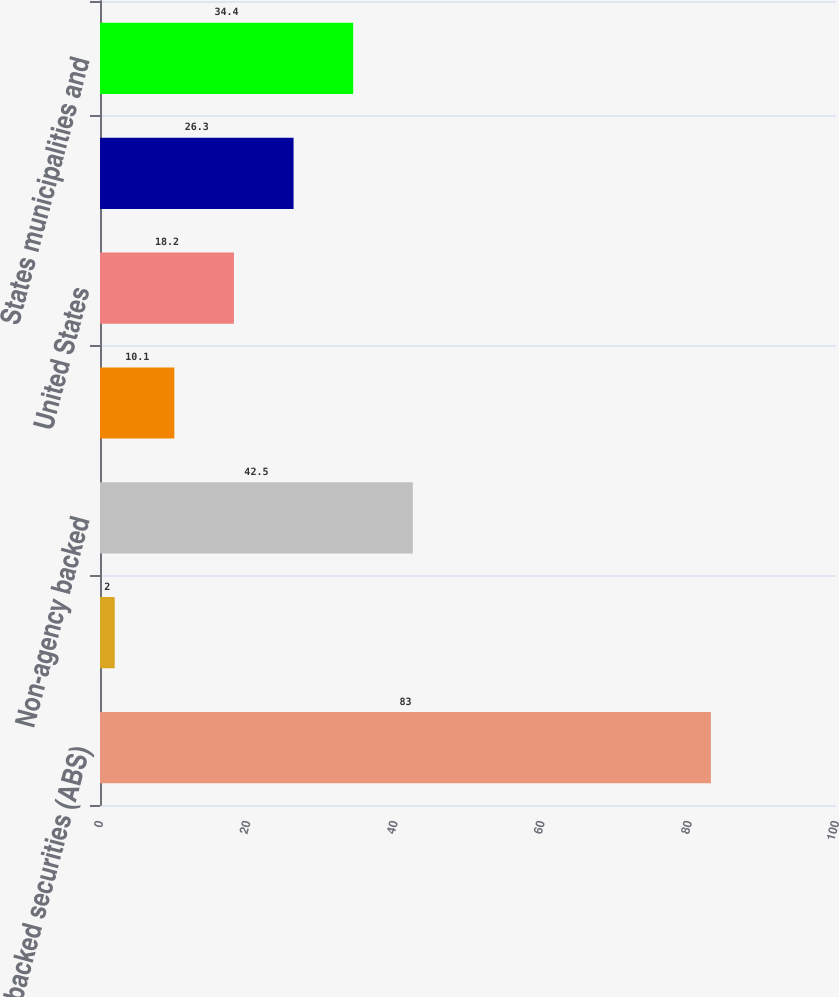<chart> <loc_0><loc_0><loc_500><loc_500><bar_chart><fcel>Asset-backed securities (ABS)<fcel>Agency backed<fcel>Non-agency backed<fcel>Foreign<fcel>United States<fcel>US Government/Government<fcel>States municipalities and<nl><fcel>83<fcel>2<fcel>42.5<fcel>10.1<fcel>18.2<fcel>26.3<fcel>34.4<nl></chart> 